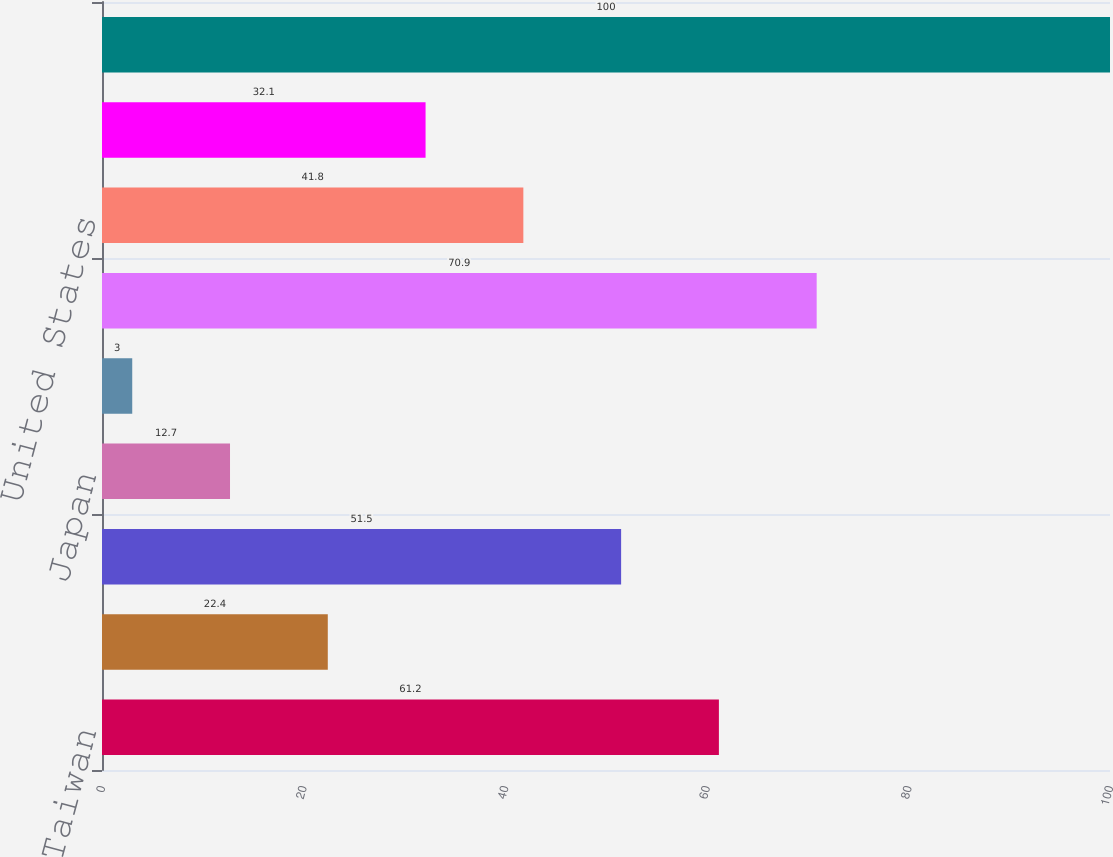<chart> <loc_0><loc_0><loc_500><loc_500><bar_chart><fcel>Taiwan<fcel>China<fcel>Korea<fcel>Japan<fcel>Southeast Asia<fcel>Asia Pacific<fcel>United States<fcel>Europe<fcel>Total<nl><fcel>61.2<fcel>22.4<fcel>51.5<fcel>12.7<fcel>3<fcel>70.9<fcel>41.8<fcel>32.1<fcel>100<nl></chart> 